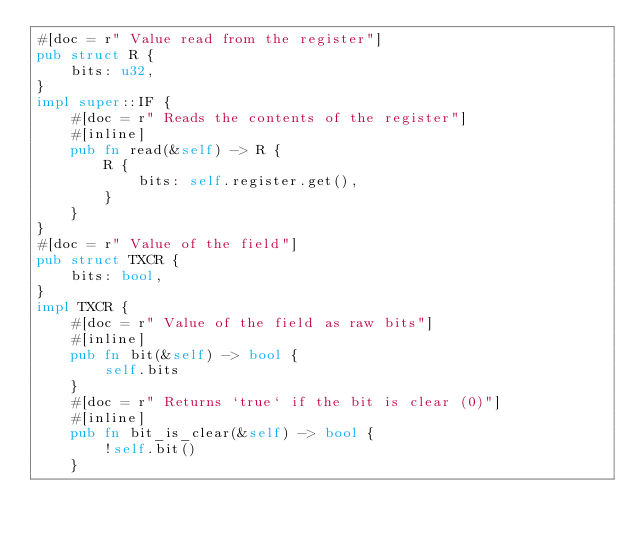Convert code to text. <code><loc_0><loc_0><loc_500><loc_500><_Rust_>#[doc = r" Value read from the register"]
pub struct R {
    bits: u32,
}
impl super::IF {
    #[doc = r" Reads the contents of the register"]
    #[inline]
    pub fn read(&self) -> R {
        R {
            bits: self.register.get(),
        }
    }
}
#[doc = r" Value of the field"]
pub struct TXCR {
    bits: bool,
}
impl TXCR {
    #[doc = r" Value of the field as raw bits"]
    #[inline]
    pub fn bit(&self) -> bool {
        self.bits
    }
    #[doc = r" Returns `true` if the bit is clear (0)"]
    #[inline]
    pub fn bit_is_clear(&self) -> bool {
        !self.bit()
    }</code> 